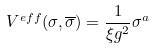<formula> <loc_0><loc_0><loc_500><loc_500>V ^ { e f f } ( \sigma , \overline { \sigma } ) = \frac { 1 } { \xi g ^ { 2 } } \sigma ^ { a }</formula> 